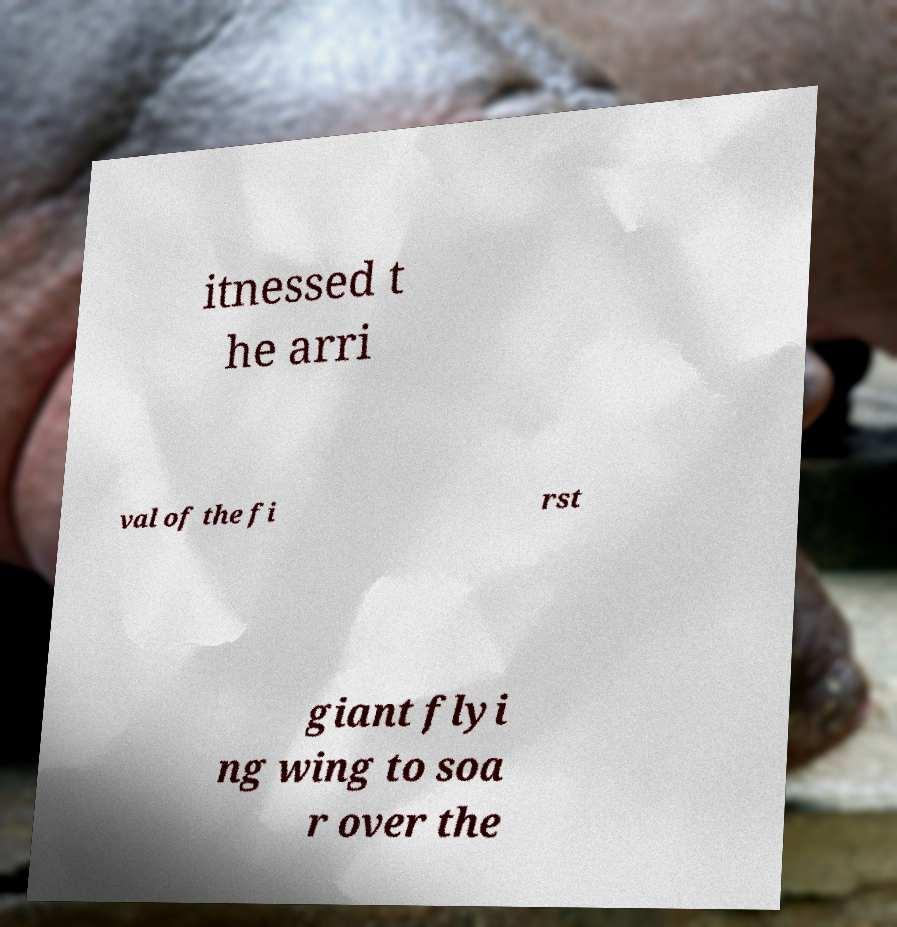Please identify and transcribe the text found in this image. itnessed t he arri val of the fi rst giant flyi ng wing to soa r over the 